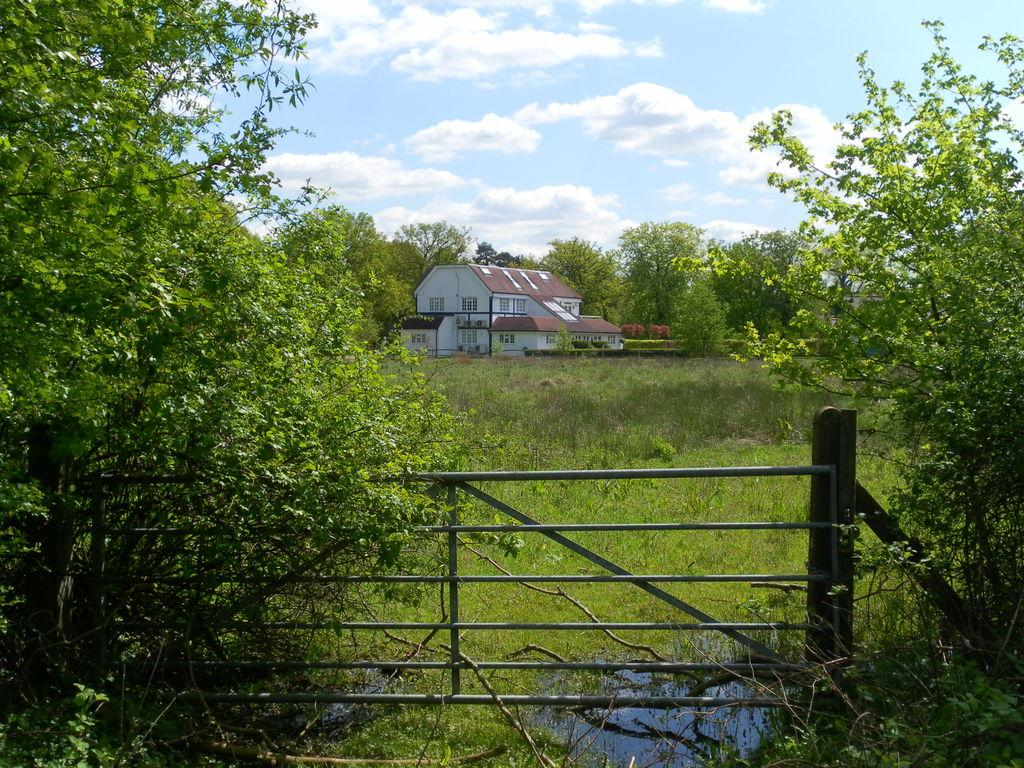What type of vegetation can be seen in the image? There are many trees, plants, and grass visible in the image. What is the primary feature of the landscape in the image? The primary feature of the landscape is the presence of vegetation, including trees, plants, and grass. What type of fencing is present in the image? There is rod fencing in the image. What type of structure can be seen in the background of the image? There is a bungalow in the background of the image. What are the characteristics of the bungalow? The bungalow has walls and windows. What is visible at the top of the image? The sky is visible at the top of the image. What is the condition of the sky in the image? The sky is cloudy in the image. Can you tell me how many ladybugs are crawling on the bungalow in the image? There are no ladybugs visible in the image; the focus is on the vegetation, fencing, and bungalow. How does the brother help with the gardening in the image? There is no mention of a brother or gardening in the image; the focus is on the landscape and the bungalow. 